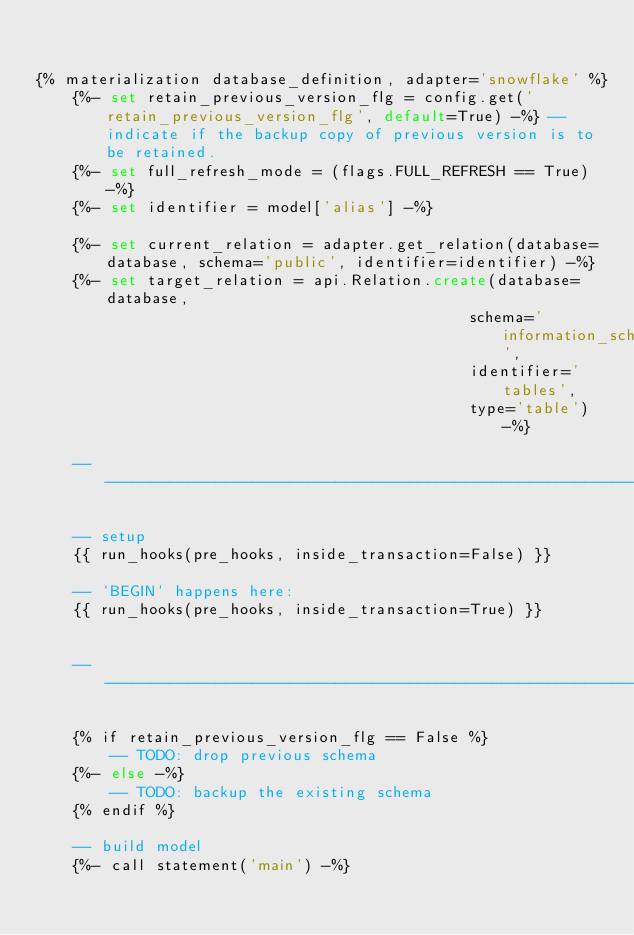Convert code to text. <code><loc_0><loc_0><loc_500><loc_500><_SQL_>

{% materialization database_definition, adapter='snowflake' %}
    {%- set retain_previous_version_flg = config.get('retain_previous_version_flg', default=True) -%} -- indicate if the backup copy of previous version is to be retained.
    {%- set full_refresh_mode = (flags.FULL_REFRESH == True) -%}
    {%- set identifier = model['alias'] -%}

    {%- set current_relation = adapter.get_relation(database=database, schema='public', identifier=identifier) -%}
    {%- set target_relation = api.Relation.create(database=database,
                                               schema='information_schema',
                                               identifier='tables',
                                               type='table') -%}

    --------------------------------------------------------------------------------------------------------------------

    -- setup
    {{ run_hooks(pre_hooks, inside_transaction=False) }}

    -- `BEGIN` happens here:
    {{ run_hooks(pre_hooks, inside_transaction=True) }}


    --------------------------------------------------------------------------------------------------------------------

    {% if retain_previous_version_flg == False %}
        -- TODO: drop previous schema
    {%- else -%}
        -- TODO: backup the existing schema
    {% endif %}

    -- build model
    {%- call statement('main') -%}</code> 